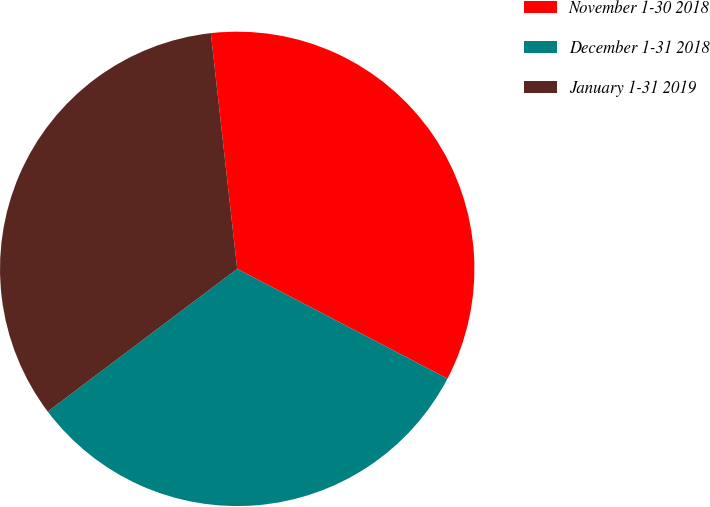Convert chart. <chart><loc_0><loc_0><loc_500><loc_500><pie_chart><fcel>November 1-30 2018<fcel>December 1-31 2018<fcel>January 1-31 2019<nl><fcel>34.43%<fcel>32.07%<fcel>33.5%<nl></chart> 